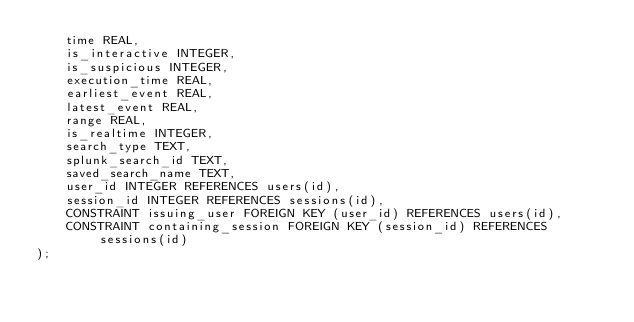Convert code to text. <code><loc_0><loc_0><loc_500><loc_500><_SQL_>    time REAL,
    is_interactive INTEGER,
    is_suspicious INTEGER,
    execution_time REAL,
    earliest_event REAL,
    latest_event REAL,
    range REAL,
    is_realtime INTEGER,
    search_type TEXT,
    splunk_search_id TEXT,
    saved_search_name TEXT,
    user_id INTEGER REFERENCES users(id),
    session_id INTEGER REFERENCES sessions(id),
    CONSTRAINT issuing_user FOREIGN KEY (user_id) REFERENCES users(id),
    CONSTRAINT containing_session FOREIGN KEY (session_id) REFERENCES sessions(id)
);
</code> 